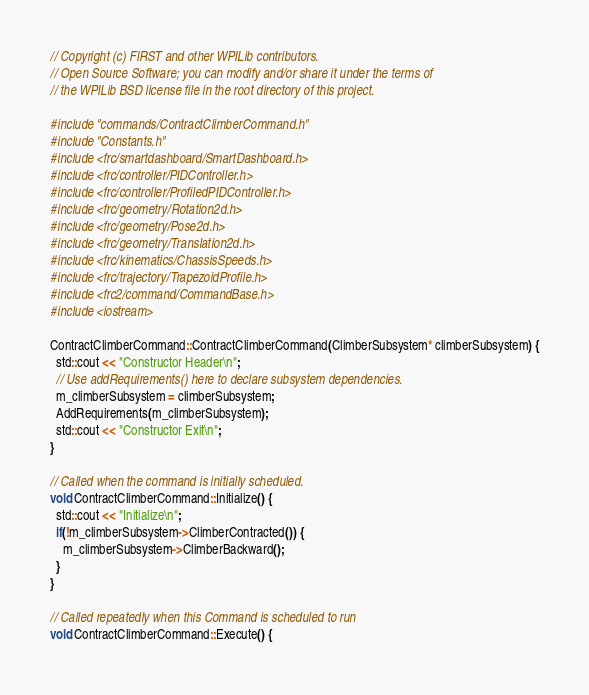Convert code to text. <code><loc_0><loc_0><loc_500><loc_500><_C++_>// Copyright (c) FIRST and other WPILib contributors.
// Open Source Software; you can modify and/or share it under the terms of
// the WPILib BSD license file in the root directory of this project.

#include "commands/ContractClimberCommand.h"
#include "Constants.h"
#include <frc/smartdashboard/SmartDashboard.h>
#include <frc/controller/PIDController.h>
#include <frc/controller/ProfiledPIDController.h>
#include <frc/geometry/Rotation2d.h>
#include <frc/geometry/Pose2d.h>
#include <frc/geometry/Translation2d.h>
#include <frc/kinematics/ChassisSpeeds.h>
#include <frc/trajectory/TrapezoidProfile.h>
#include <frc2/command/CommandBase.h>
#include <iostream>

ContractClimberCommand::ContractClimberCommand(ClimberSubsystem* climberSubsystem) {
  std::cout << "Constructor Header\n";
  // Use addRequirements() here to declare subsystem dependencies.
  m_climberSubsystem = climberSubsystem;
  AddRequirements(m_climberSubsystem);
  std::cout << "Constructor Exit\n";
}

// Called when the command is initially scheduled.
void ContractClimberCommand::Initialize() {
  std::cout << "Initialize\n";
  if(!m_climberSubsystem->ClimberContracted()) {
    m_climberSubsystem->ClimberBackward();
  }
}

// Called repeatedly when this Command is scheduled to run
void ContractClimberCommand::Execute() {</code> 